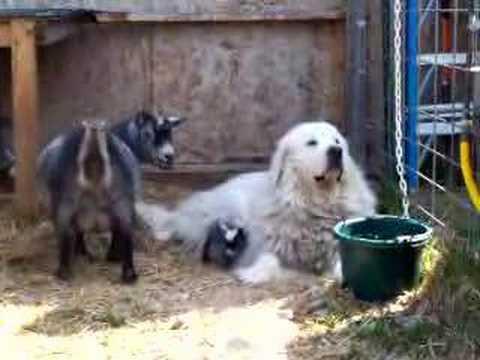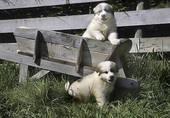The first image is the image on the left, the second image is the image on the right. For the images displayed, is the sentence "There is a picture of a dog and a goat together." factually correct? Answer yes or no. Yes. The first image is the image on the left, the second image is the image on the right. Given the left and right images, does the statement "At least one white dog is in a scene with goats, and a fence is present in each image." hold true? Answer yes or no. Yes. 